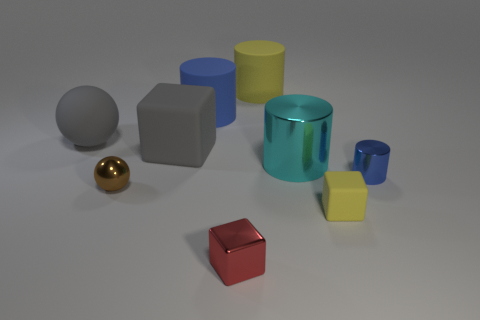Subtract all large gray blocks. How many blocks are left? 2 Subtract all blue cylinders. How many cylinders are left? 2 Subtract 2 blocks. How many blocks are left? 1 Add 5 big yellow shiny balls. How many big yellow shiny balls exist? 5 Subtract 1 blue cylinders. How many objects are left? 8 Subtract all cubes. How many objects are left? 6 Subtract all red cylinders. Subtract all cyan blocks. How many cylinders are left? 4 Subtract all blue spheres. How many gray cubes are left? 1 Subtract all yellow rubber things. Subtract all small metallic objects. How many objects are left? 4 Add 4 small yellow cubes. How many small yellow cubes are left? 5 